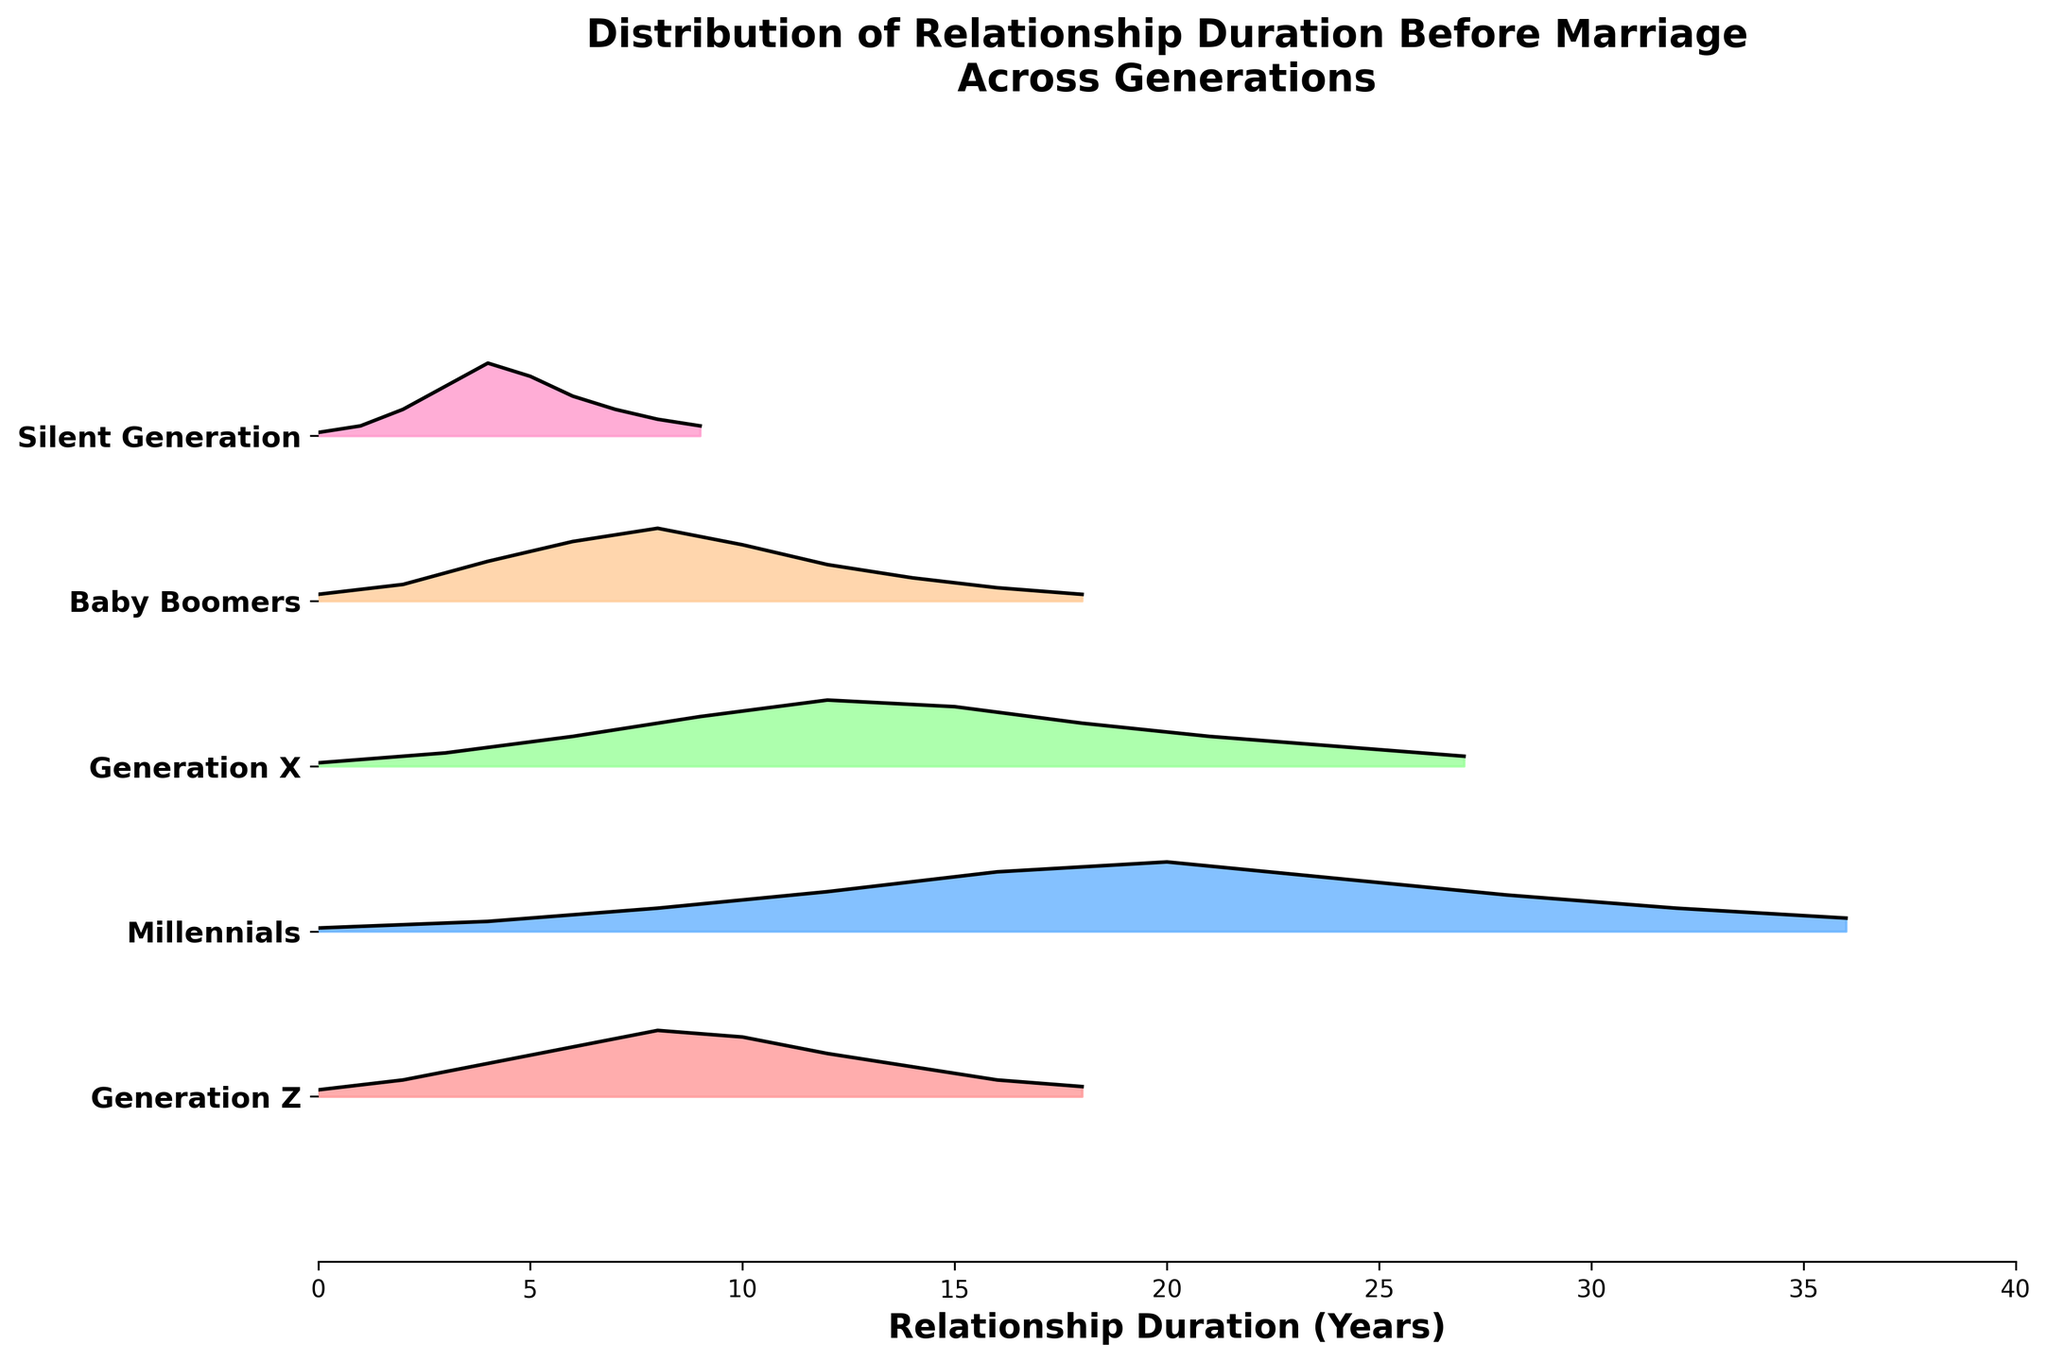What's the title of the figure? The title is displayed at the top of the figure. It reads "Distribution of Relationship Duration Before Marriage Across Generations".
Answer: Distribution of Relationship Duration Before Marriage Across Generations Which generation has the highest density peak for relationship duration before marriage? By examining the plot, we can see the highest peak in density for each generation. The Millennials have the highest peak at around 0.21 density at approximately 20 years duration.
Answer: Millennials How does the peak density of Generation Z compare to the peak densitiy of Baby Boomers? Generation Z has a peak density of around 0.20, while the Baby Boomers' peak density is around 0.22. To compare, subtract the two densities: 0.22 - 0.20 = 0.02. Therefore, Baby Boomers have a peak density 0.02 higher than Generation Z.
Answer: Baby Boomers have a higher peak density by 0.02 What is the approximate relationship duration before marriage for the Silent Generation's density peak? Locate the highest point on the Silent Generation curve. The peak of the Silent Generation's density is around 4 years duration.
Answer: 4 years Which generation shows the broadest distribution of relationship duration before marriage? The broad distribution can be identified by observing the spread of the densities across the duration axis. Millennials display a broader distribution as their densities spread up to around 36 years.
Answer: Millennials Which generation has a density peak around 10 years of relationship duration before marriage? By observing the figure, the Baby Boomers have a noticeable density peak around the 10-year mark.
Answer: Baby Boomers What is the approximate density for Generation X at 15 years of relationship duration before marriage? Look for Generation X on the plot and find approximately where the 15 years mark is. The density at that point is about 0.18.
Answer: 0.18 Which generation has the least density at zero years of relationship duration before marriage? Compare the densities at the zero-year mark for all generations. Generation X has the lowest density, around 0.01.
Answer: Generation X How does the relationship duration distribution before marriage change over generations? Starting with the Silent Generation, the peak durations gradually shift to longer durations in subsequent generations. The density peaks are highest for Millennials, indicating longer relationships before marriage becoming more common over time.
Answer: Trends towards longer relationships over generations What relationship duration range accounts for the highest density among Millennials? For Millennials, the highest density is around the 20-year mark, and the density stays relatively high from around 12 to 28 years.
Answer: 12-28 years 